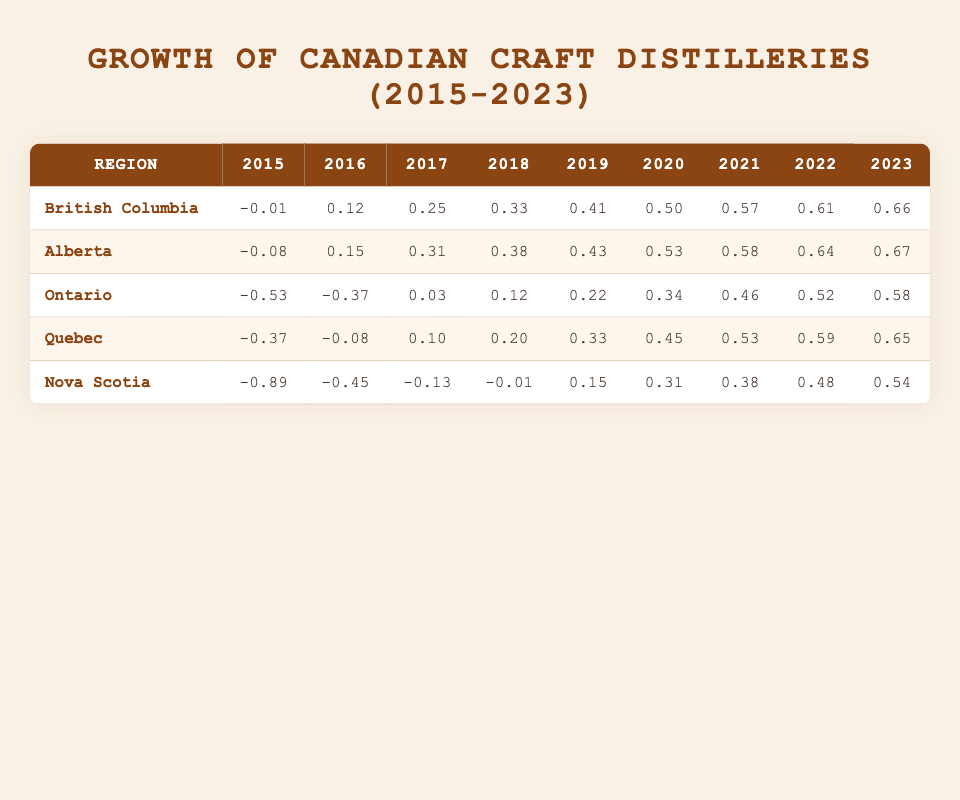What was the growth rate for Alberta in 2023? The table lists the growth rate for Alberta in 2023 under the corresponding column, which shows 7.1.
Answer: 7.1 Which region had the highest growth rate in 2022? By comparing the 2022 values for each region, Alberta has the highest with a growth rate of 6.7 while others are lower.
Answer: Alberta What is the difference in growth rate between British Columbia in 2015 and in 2023? The growth rate for British Columbia in 2015 is 2.7, and in 2023 it is 6.9. The difference is 6.9 - 2.7 = 4.2.
Answer: 4.2 Is it true that Nova Scotia had a growth rate lower than 6.0 in every year from 2015 to 2022? In the table, Nova Scotia's growth rates for 2015 to 2022 are 1.5, 1.9, 2.4, 2.7, 3.2, 3.9, 4.3, and 5.0, which are all lower than 6.0. Thus, the statement is true.
Answer: Yes What is the average growth rate for Ontario from 2015 to 2023? The growth rates for Ontario are 1.8, 2.0, 2.8, 3.1, 3.5, 4.1, 4.9, 5.4, and 6.0. To find the average, we sum these (1.8 + 2.0 + 2.8 + 3.1 + 3.5 + 4.1 + 4.9 + 5.4 + 6.0 = 33.6) and divide by the number of years (9), yielding an average of 33.6 / 9 = 3.73.
Answer: 3.73 Which region experienced the most significant increase in growth rate from 2015 to 2023? To find the region with the most significant increase, we subtract the 2015 value from the 2023 value for each region: British Columbia (6.9 - 2.7 = 4.2), Alberta (7.1 - 2.5 = 4.6), Ontario (6.0 - 1.8 = 4.2), Quebec (6.8 - 2.0 = 4.8), Nova Scotia (5.6 - 1.5 = 4.1). The largest increase is 4.8 for Quebec.
Answer: Quebec 